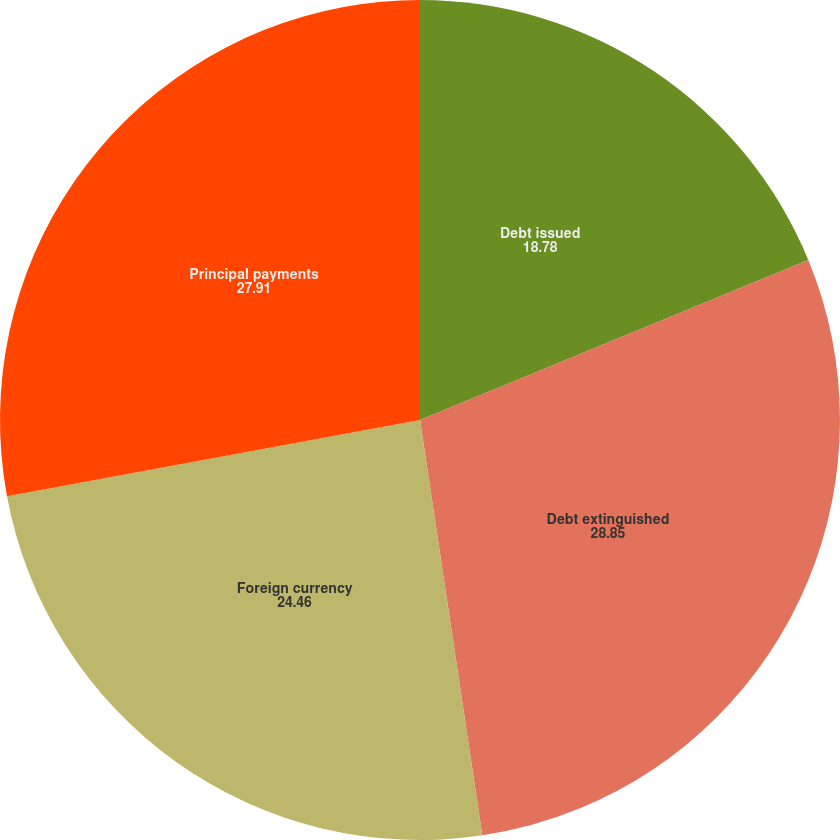<chart> <loc_0><loc_0><loc_500><loc_500><pie_chart><fcel>Debt issued<fcel>Debt extinguished<fcel>Foreign currency<fcel>Principal payments<nl><fcel>18.78%<fcel>28.85%<fcel>24.46%<fcel>27.91%<nl></chart> 